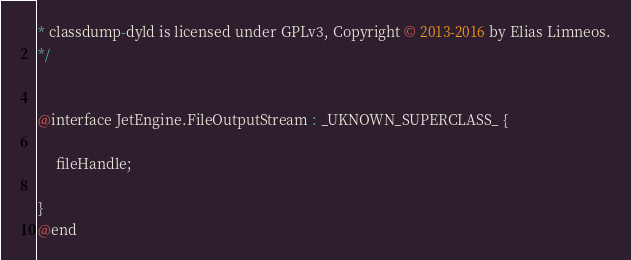Convert code to text. <code><loc_0><loc_0><loc_500><loc_500><_C_>* classdump-dyld is licensed under GPLv3, Copyright © 2013-2016 by Elias Limneos.
*/


@interface JetEngine.FileOutputStream : _UKNOWN_SUPERCLASS_ {

	 fileHandle;

}
@end

</code> 